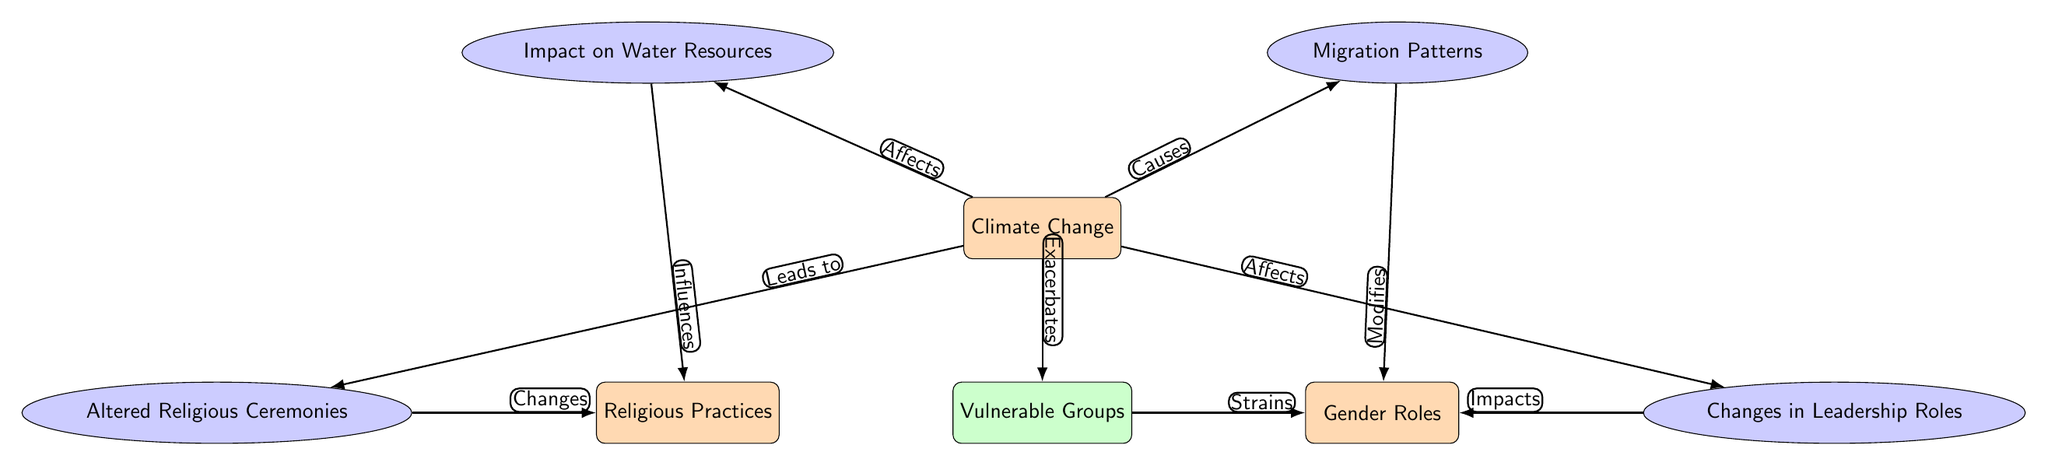What is the main focus of the diagram? The main focus of the diagram is represented by the first node labeled "Climate Change". It is the starting point from which all relationships and influences branch out in the diagram.
Answer: Climate Change How many main nodes are in the diagram? There are three main nodes in the diagram: "Climate Change," "Religious Practices," and "Gender Roles." By counting the rectangular nodes which are categorized as main nodes, we find there are a total of three.
Answer: 3 What relationship does climate change have with vulnerable groups? In the diagram, the relationship is indicated by the edge labeled "Exacerbates," showing that climate change has a negative effect on vulnerable groups. This connection is made through a directed edge leading from "Climate Change" to "Vulnerable Groups."
Answer: Exacerbates What influences altered religious ceremonies? "Climate Change" leads to "Altered Religious Ceremonies," indicating that climate change has a direct influence on how religious ceremonies are conducted. The edge labeled "Leads to" conveys this relationship.
Answer: Climate Change Which factor causes changes in gender roles? "Migration Patterns" is highlighted as a factor that modifies gender roles in the diagram. The edge labeled "Modifies" between the nodes indicates this influence clearly.
Answer: Migration Patterns How does climate change impact leadership roles? The arrow from "Climate Change" to "Changes in Leadership Roles" indicates that climate change has a direct impact on leadership roles within communities, as shown by the edge labeled "Affects."
Answer: Affects What is the relationship between vulnerable groups and gender roles? The path shows that vulnerable groups strain gender roles, indicated by the directed edge labeled "Strains." This means that the condition of vulnerable groups leads to a tension in gender roles as conveyed by the arrows in the diagram.
Answer: Strains What type of node is "Altered Religious Ceremonies" in the diagram? "Altered Religious Ceremonies" is classified as a secondary node, which can be identified by its shape (ellipse) and its relationship to the main node of climate change.
Answer: Secondary What encompasses the overall influence of climate change on social structures? The overall influence is depicted as various pathways leading from climate change, affecting aspects like water resources, migration patterns, and changes in both religious practices and gender roles, making it a complex network of impacts in society.
Answer: Complex network 